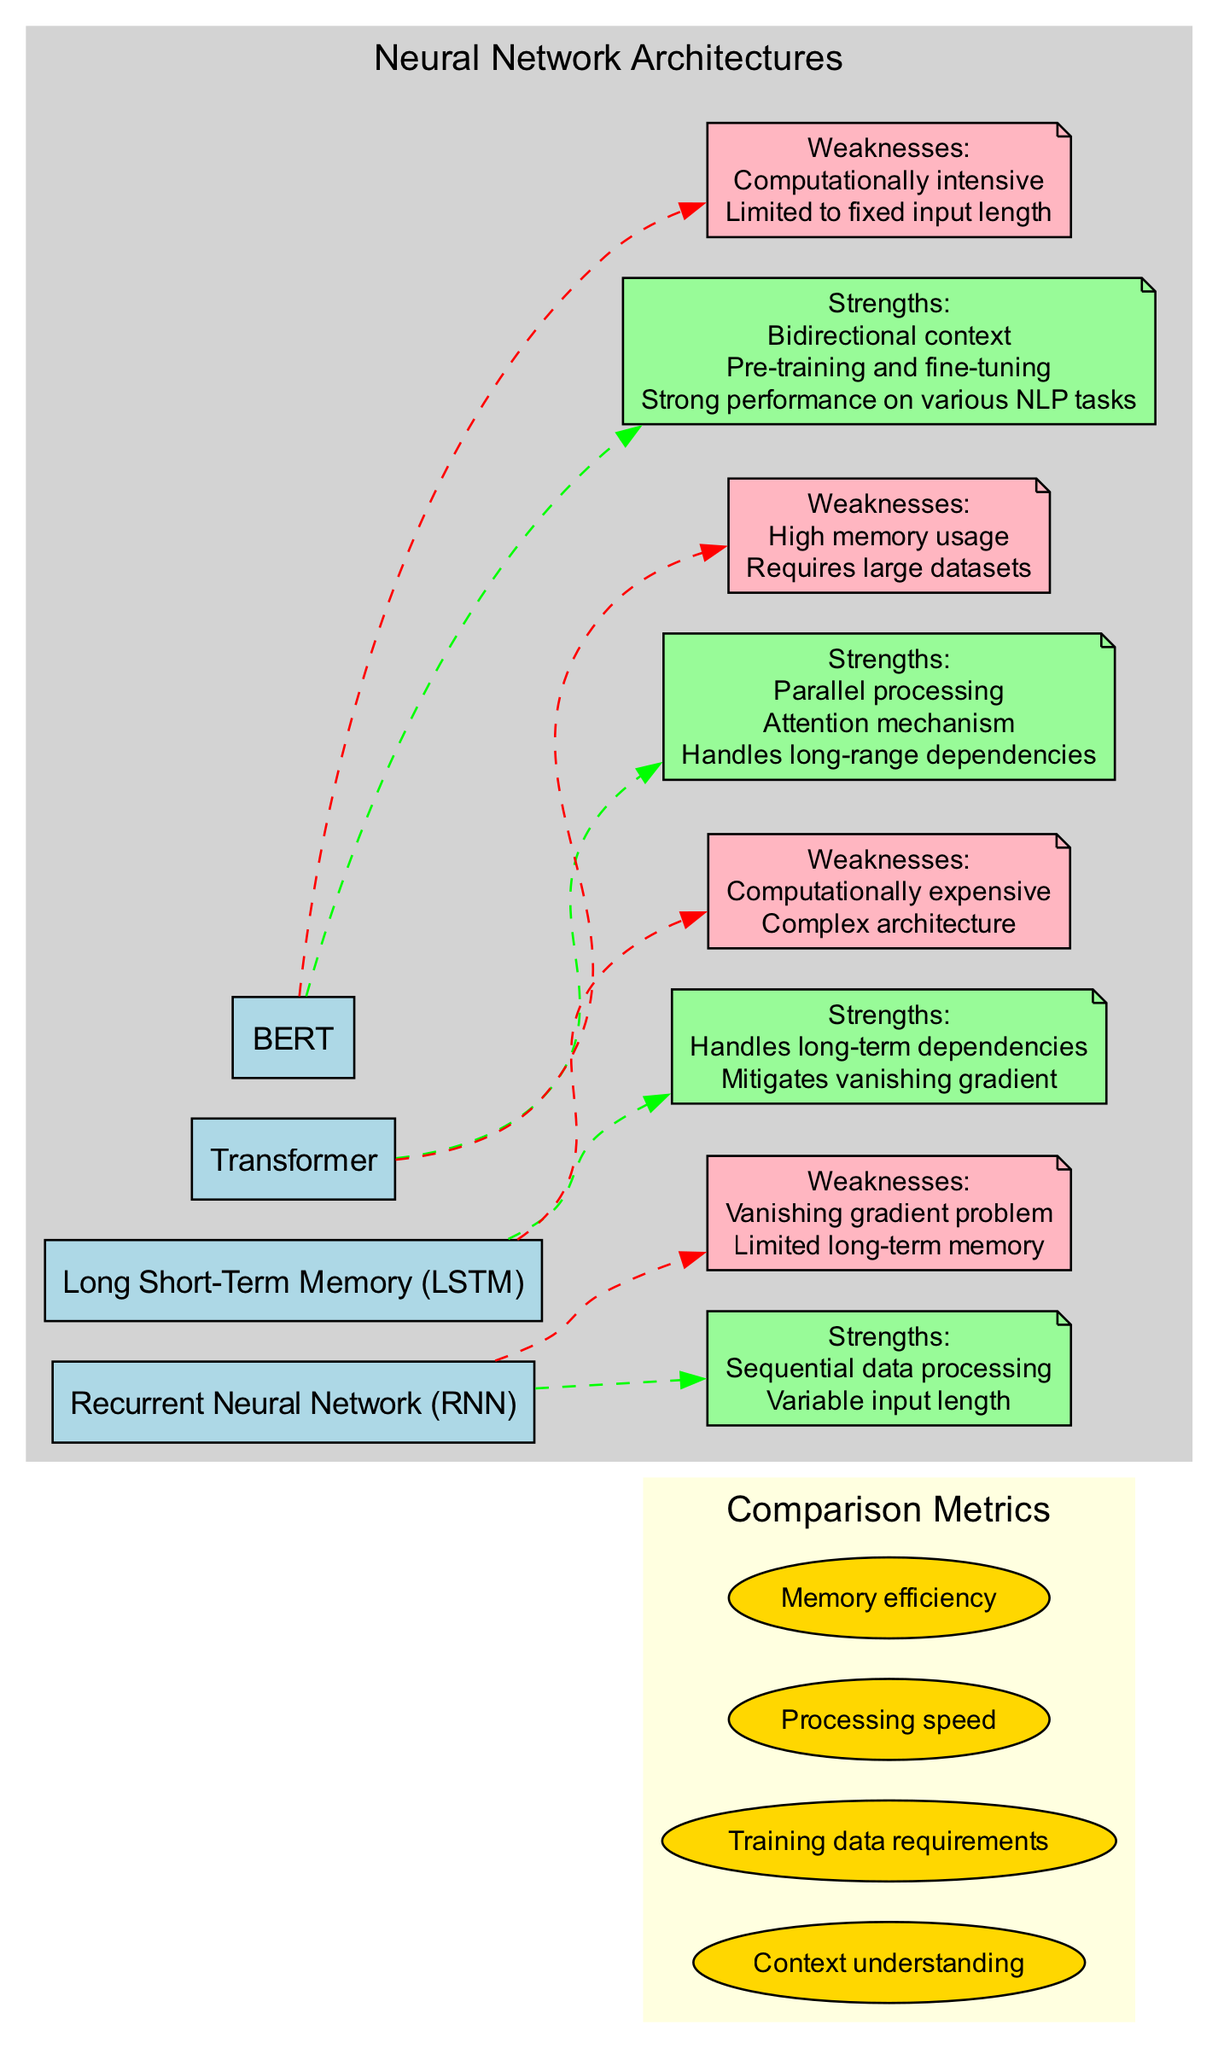What are the strengths of Long Short-Term Memory? The strengths of Long Short-Term Memory can be found in the box associated with it in the diagram, where it lists "Handles long-term dependencies" and "Mitigates vanishing gradient."
Answer: Handles long-term dependencies, mitigates vanishing gradient How many architectures are represented in the diagram? By counting the architecture nodes in the diagram, we can determine that there are four architectures: RNN, LSTM, Transformer, and BERT.
Answer: Four What is the weakness of the Transformer architecture? The weaknesses are displayed in a note connected to the Transformer node. The diagram states "High memory usage" and "Requires large datasets."
Answer: High memory usage, requires large datasets Which architecture has bidirectional context as a strength? The strength is indicated in the BERT box. Bidirectional context is specifically listed as a strength unique to BERT.
Answer: BERT Which architecture is described as computationally expensive? This can be found under both the LSTM and BERT nodes in their respective weaknesses. Both architectures have "Computationally expensive" listed as a weakness.
Answer: LSTM, BERT What metric is related to context understanding in the comparisons? The metric is listed in the comparison metrics section of the diagram. It is "Context understanding," which directly relates to how well the architectures can process and interpret language context.
Answer: Context understanding Which architecture has high memory usage as a weakness? The diagram indicates this weakness directly under the Transformer node, confirming that it is the architecture associated with high memory usage.
Answer: Transformer How many strengths does the Recurrent Neural Network have? By examining the strengths column connected to the RNN node, we can see there are two listed strengths: "Sequential data processing" and "Variable input length."
Answer: Two 